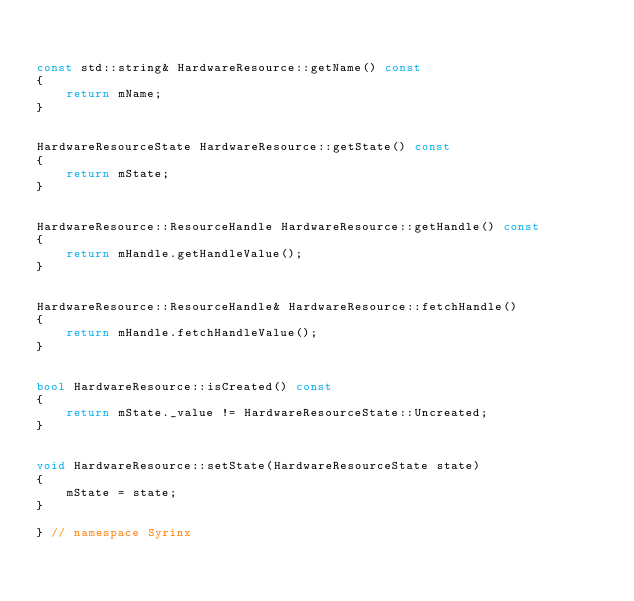<code> <loc_0><loc_0><loc_500><loc_500><_C++_>

const std::string& HardwareResource::getName() const
{
    return mName;
}


HardwareResourceState HardwareResource::getState() const
{
    return mState;
}


HardwareResource::ResourceHandle HardwareResource::getHandle() const
{
    return mHandle.getHandleValue();
}


HardwareResource::ResourceHandle& HardwareResource::fetchHandle()
{
    return mHandle.fetchHandleValue();
}


bool HardwareResource::isCreated() const
{
    return mState._value != HardwareResourceState::Uncreated;
}


void HardwareResource::setState(HardwareResourceState state)
{
    mState = state;
}

} // namespace Syrinx
</code> 